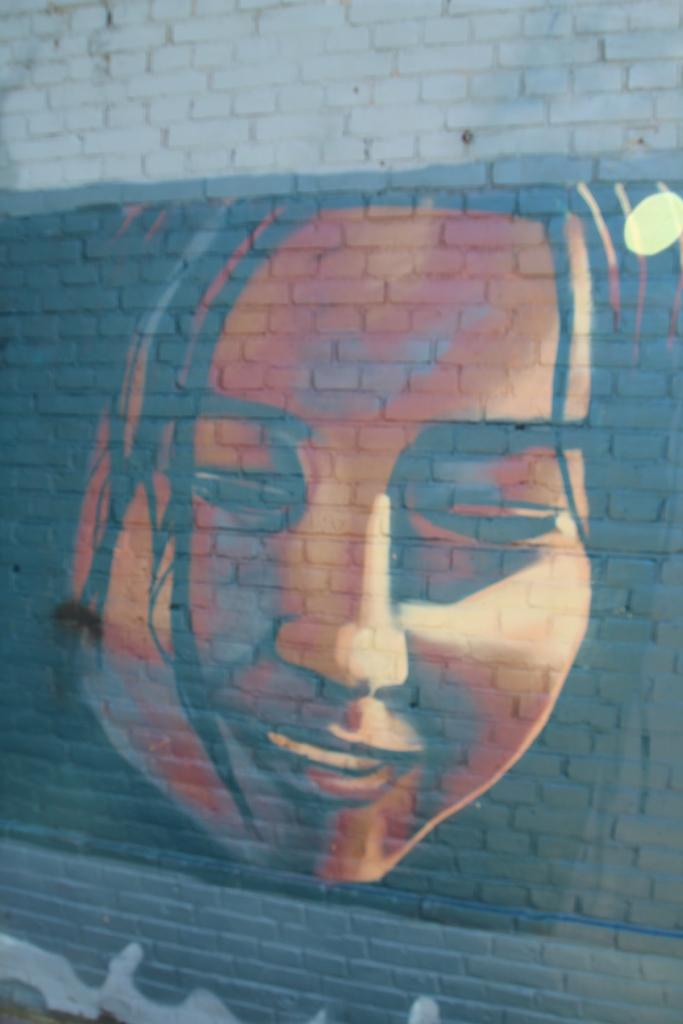What is depicted on the wall in the image? There is a picture of a person's face on the wall in the image. What type of metal is the pot used for cooking in the image? There is no pot used for cooking present in the image. 